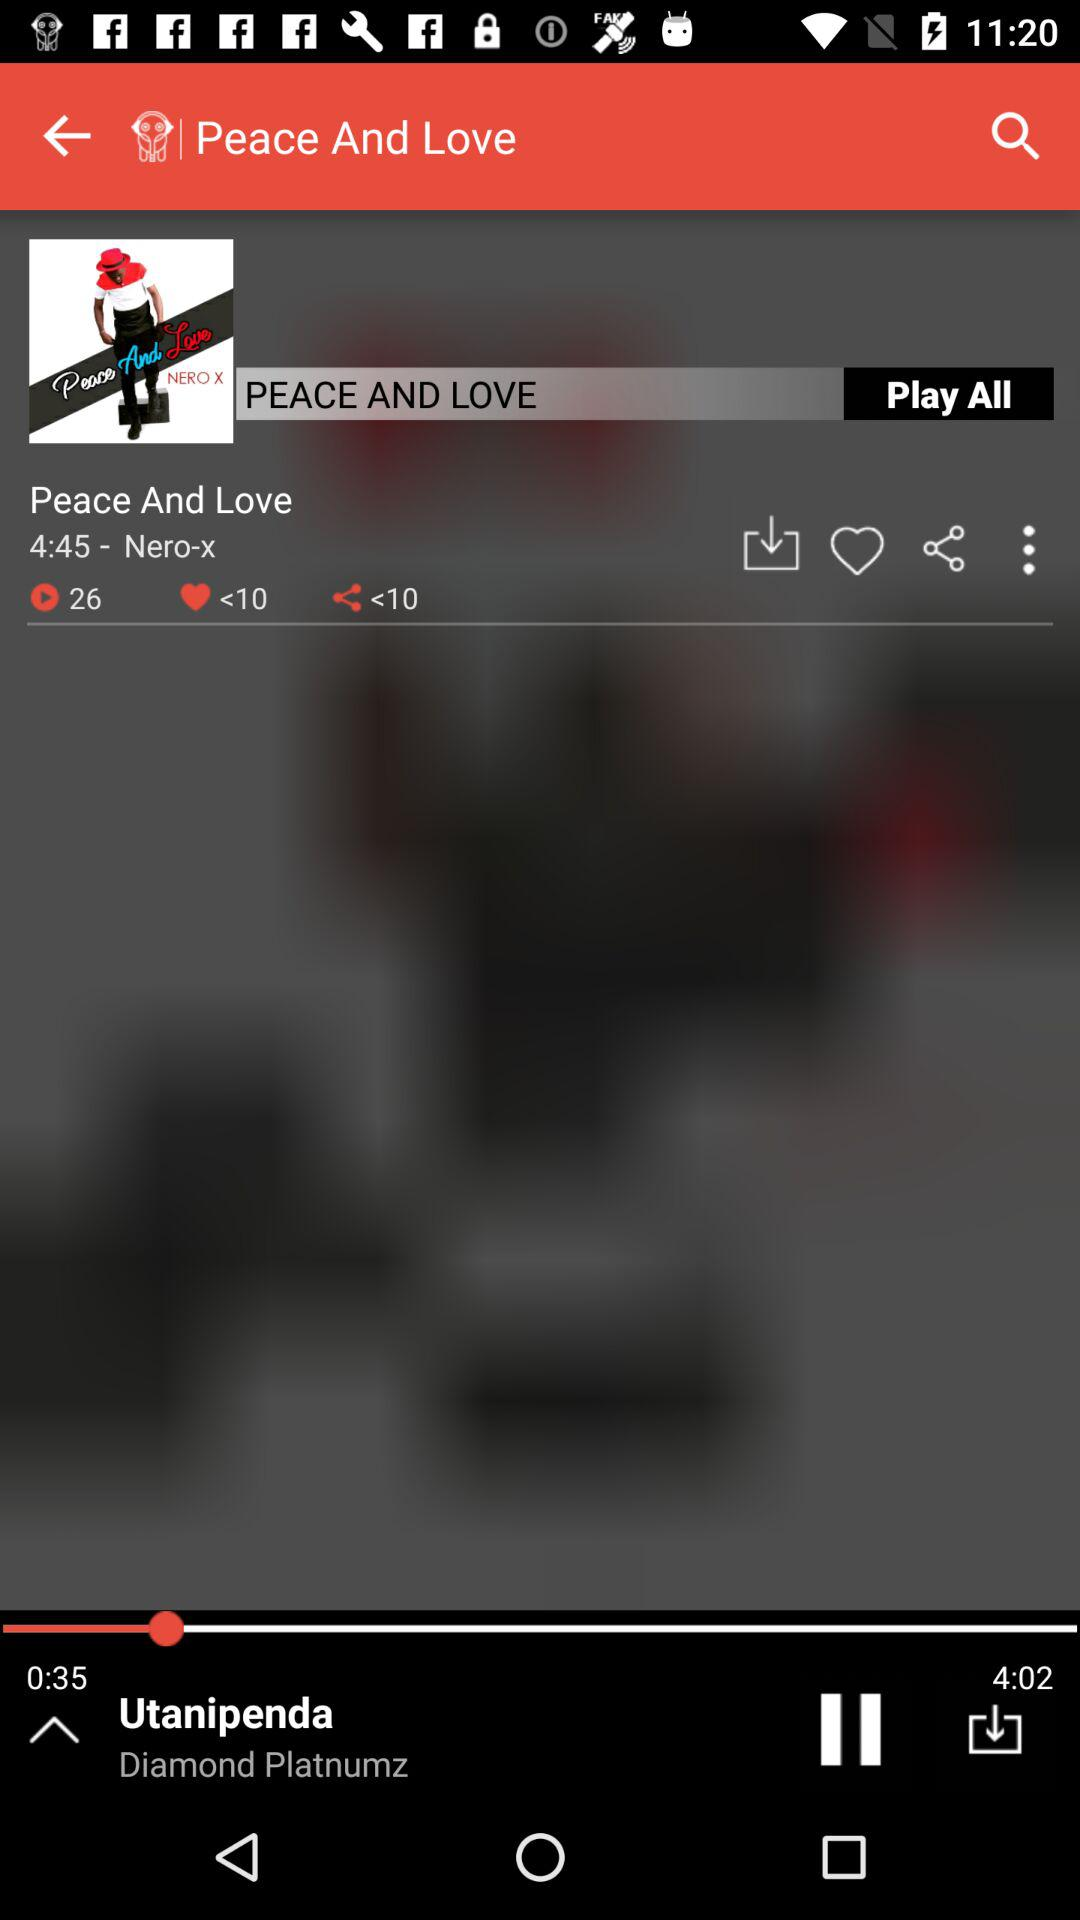What is the number of shares? The number of shares is "<10". 